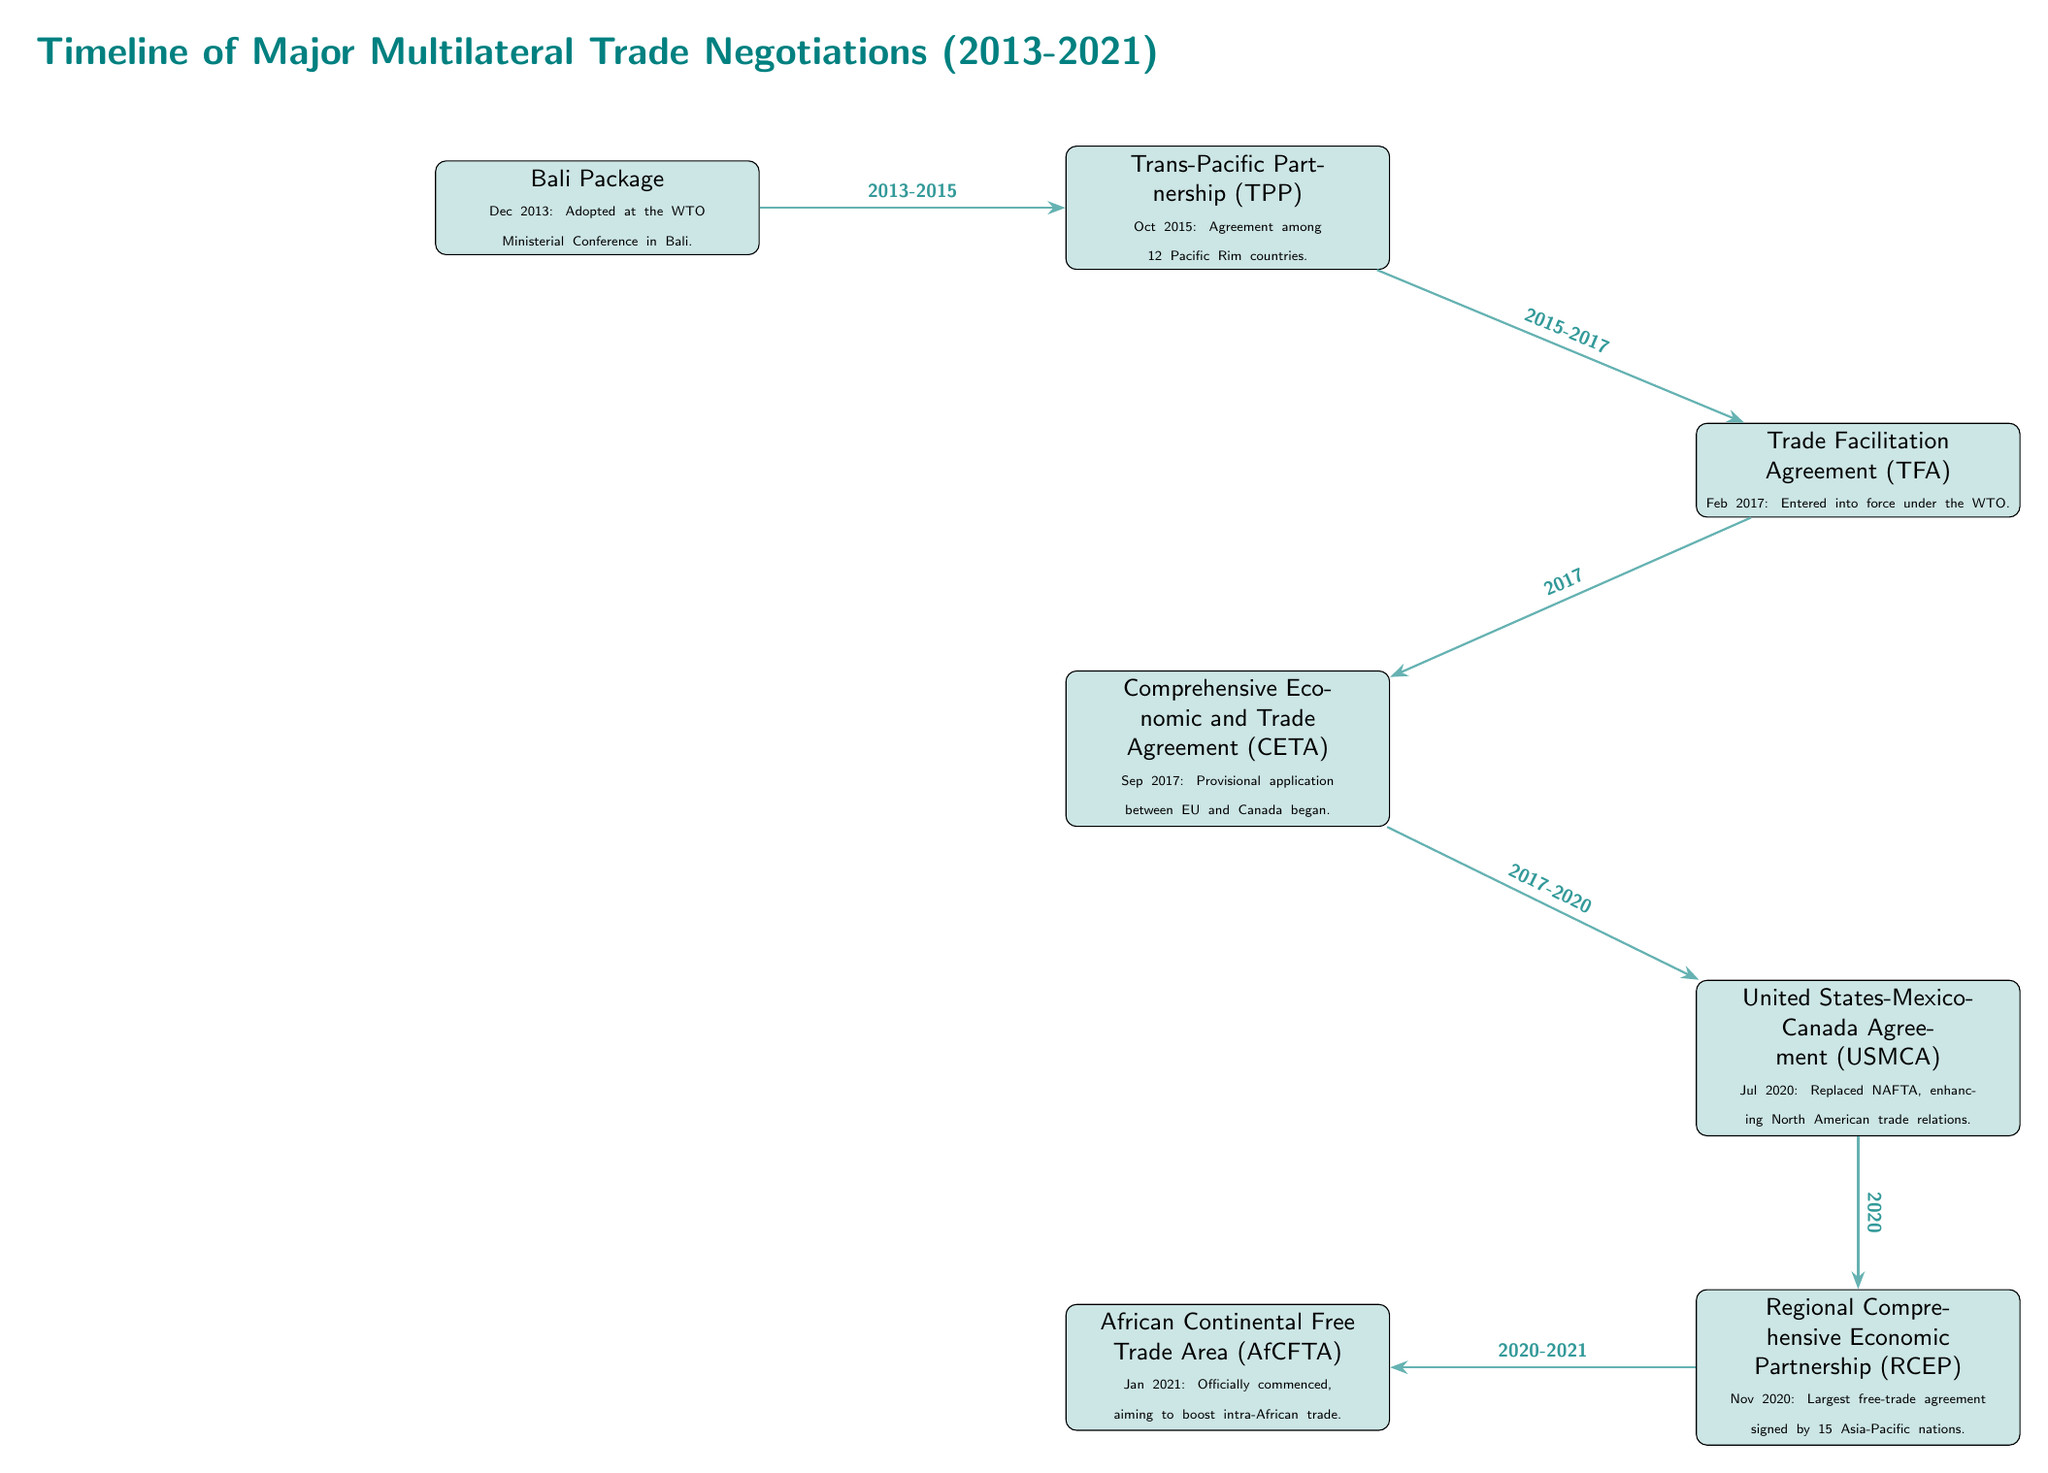What is the first major trade agreement listed in the diagram? The first event in the timeline is the Bali Package, which is highlighted at the top of the diagram.
Answer: Bali Package How many major trade agreements are represented in the diagram? By counting the nodes in the diagram, there are a total of seven major trade agreements listed.
Answer: 7 Which event is shown to occur right after the Trans-Pacific Partnership? According to the arrows in the diagram, the Trade Facilitation Agreement follows the Trans-Pacific Partnership directly, indicating a chronological order.
Answer: Trade Facilitation Agreement In what year did the Regional Comprehensive Economic Partnership occur? The diagram explicitly states that the Regional Comprehensive Economic Partnership was signed in November 2020.
Answer: 2020 What is the relationship timeline between CETA and the USMCA? The diagram illustrates that the CETA was established in 2017 and the USMCA came about after CETA, specifically in July 2020, as indicated by the arrow connecting the two.
Answer: 2017-2020 Which two agreements form a continuous path starting from the Bali Package? The Bali Package leads directly to the Trans-Pacific Partnership, followed by the Trade Facilitation Agreement, forming a sequential connection.
Answer: Trans-Pacific Partnership and Trade Facilitation Agreement What is the last trade agreement mentioned in the timeline? The last node in the downward flow of the timeline is labeled African Continental Free Trade Area, marking it as the final agreement in the sequence.
Answer: African Continental Free Trade Area How long did the period between the Bali Package and the TPP last? The diagram notes that the relationship between Bali Package and TPP spans a timeframe from 2013 to 2015, indicating a two-year duration.
Answer: 2 years What is unique about the RCEP in terms of the number of countries involved? The diagram specifies that RCEP is described as the "largest free-trade agreement signed by 15 Asia-Pacific nations," highlighting its extensive participation.
Answer: 15 Asia-Pacific nations 